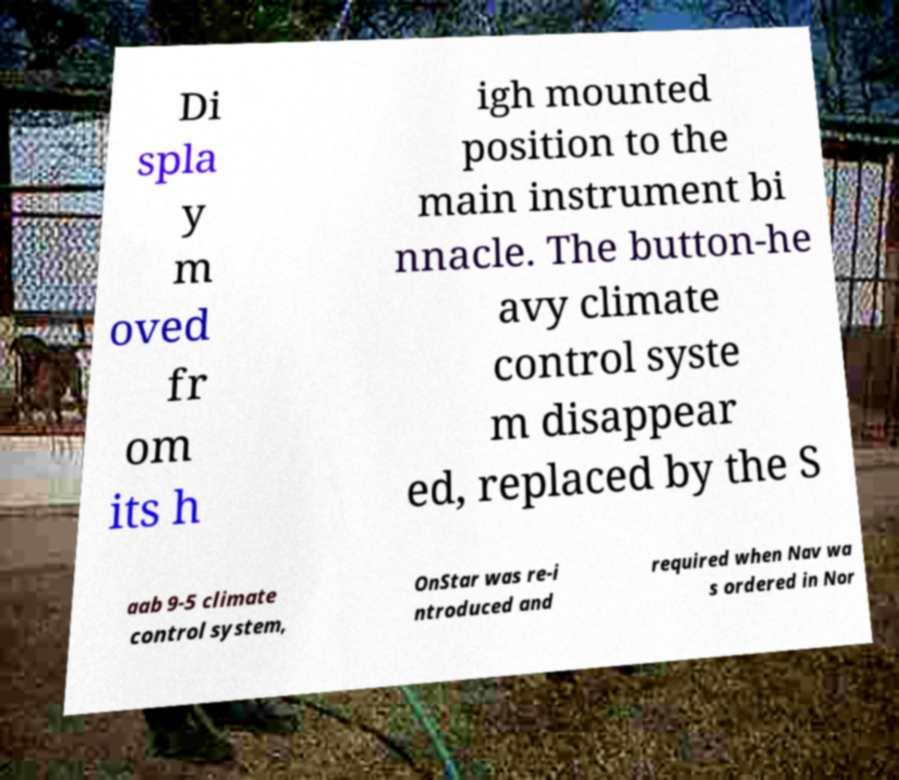Please identify and transcribe the text found in this image. Di spla y m oved fr om its h igh mounted position to the main instrument bi nnacle. The button-he avy climate control syste m disappear ed, replaced by the S aab 9-5 climate control system, OnStar was re-i ntroduced and required when Nav wa s ordered in Nor 